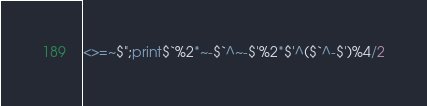<code> <loc_0><loc_0><loc_500><loc_500><_Perl_><>=~$";print$`%2*~-$`^~-$'%2*$'^($`^-$')%4/2</code> 